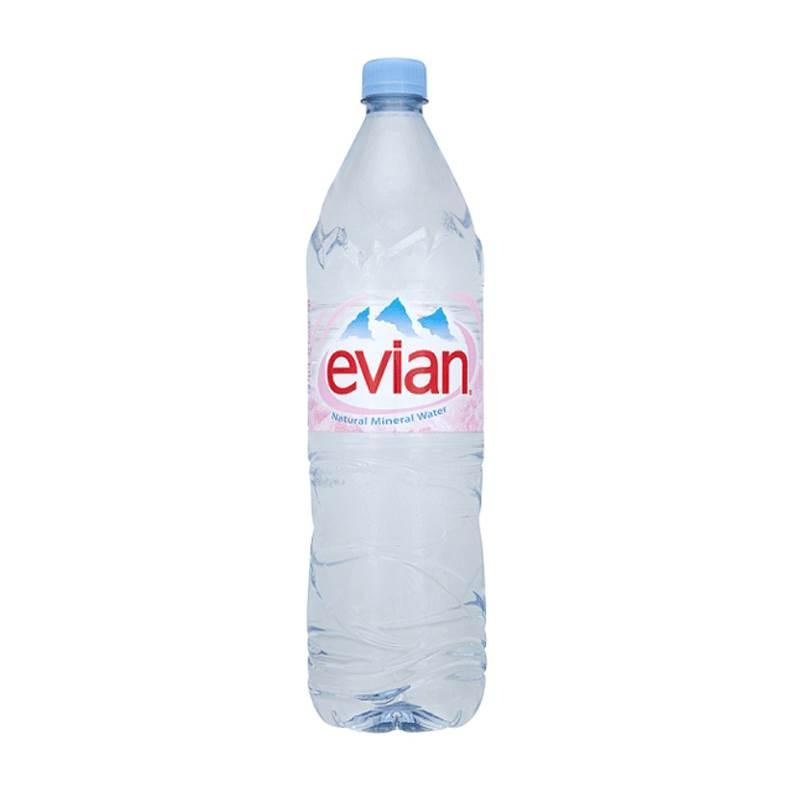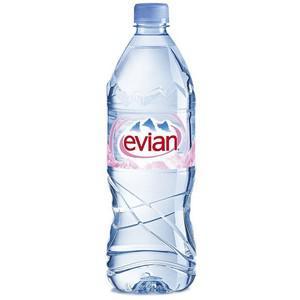The first image is the image on the left, the second image is the image on the right. For the images shown, is this caption "There are four water bottles with red labels." true? Answer yes or no. No. The first image is the image on the left, the second image is the image on the right. Evaluate the accuracy of this statement regarding the images: "Two bottles of water are the same shape and coloring, and have white caps, but have different labels.". Is it true? Answer yes or no. No. 